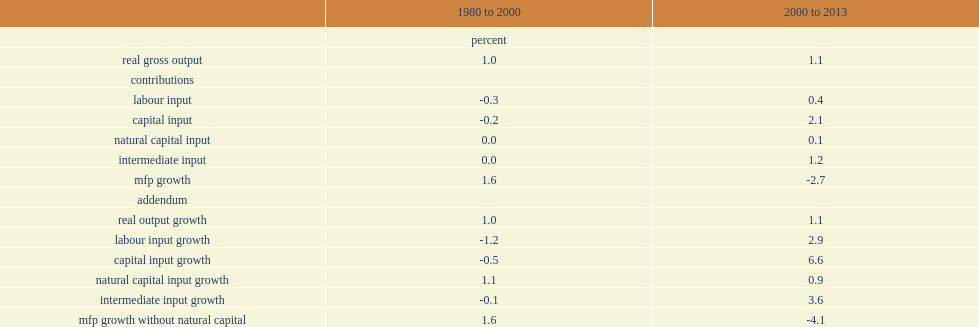What's the percent that mfp growth had of the increase from 1980 to 2000? 1.6. What's the percent that mfp growth had of the decrease from 2000 to 2013? 4.1. What's the percent that the slowdown in mtp grouth is over the two periods? 5.7. What's the percent of the slowdown in mfp growth in the two periods? 4.3. What's the percent of the increase in mfp growth from 1980 to 2000? 1.6. What's the percent of the decrease in mfp growth from 2000 to 2013? 2.7. 